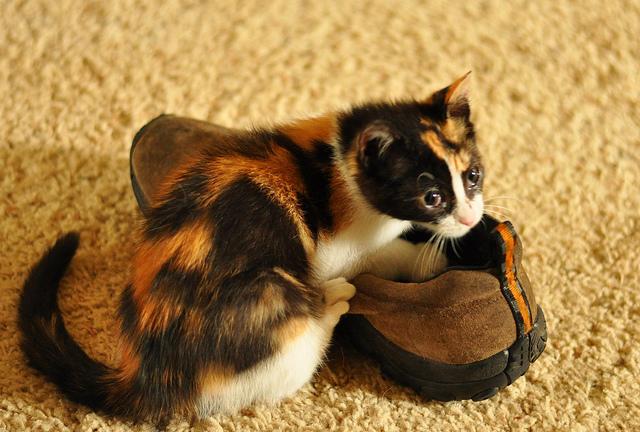Is this an adult cat?
Write a very short answer. No. Is the cat feral?
Keep it brief. No. Is the slipper really big or is the cat really little?
Write a very short answer. Cat is little. 